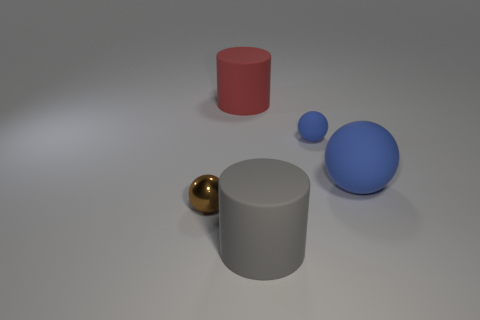Is there any other thing that has the same material as the brown sphere?
Offer a terse response. No. What is the color of the matte object that is behind the large matte sphere and to the right of the gray rubber object?
Keep it short and to the point. Blue. What number of blue spheres are the same size as the brown metal thing?
Offer a very short reply. 1. The small thing that is on the left side of the large rubber cylinder behind the tiny shiny sphere is what shape?
Offer a terse response. Sphere. What is the shape of the tiny object on the right side of the big rubber cylinder to the right of the rubber object that is on the left side of the large gray object?
Offer a terse response. Sphere. What number of other blue objects have the same shape as the small shiny object?
Make the answer very short. 2. What number of large gray rubber cylinders are behind the large matte cylinder that is behind the small metal object?
Provide a short and direct response. 0. What number of rubber things are small brown things or purple cubes?
Keep it short and to the point. 0. Are there any spheres made of the same material as the red thing?
Make the answer very short. Yes. How many things are either big red cylinders that are behind the brown thing or big cylinders left of the big gray matte thing?
Make the answer very short. 1. 